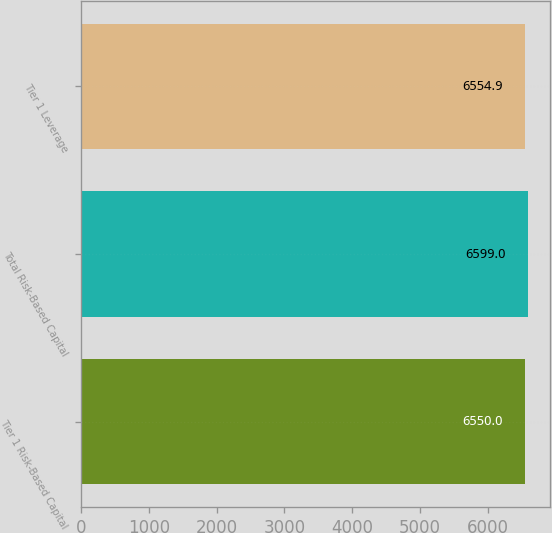Convert chart. <chart><loc_0><loc_0><loc_500><loc_500><bar_chart><fcel>Tier 1 Risk-Based Capital<fcel>Total Risk-Based Capital<fcel>Tier 1 Leverage<nl><fcel>6550<fcel>6599<fcel>6554.9<nl></chart> 